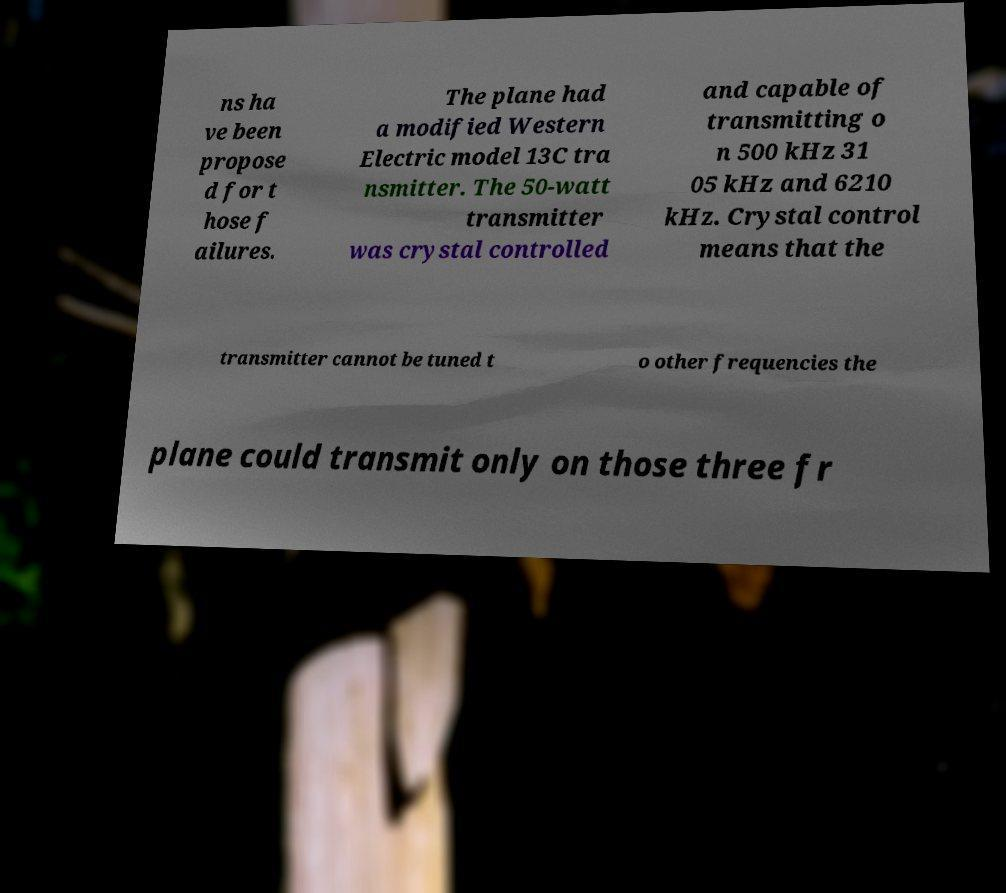There's text embedded in this image that I need extracted. Can you transcribe it verbatim? ns ha ve been propose d for t hose f ailures. The plane had a modified Western Electric model 13C tra nsmitter. The 50-watt transmitter was crystal controlled and capable of transmitting o n 500 kHz 31 05 kHz and 6210 kHz. Crystal control means that the transmitter cannot be tuned t o other frequencies the plane could transmit only on those three fr 